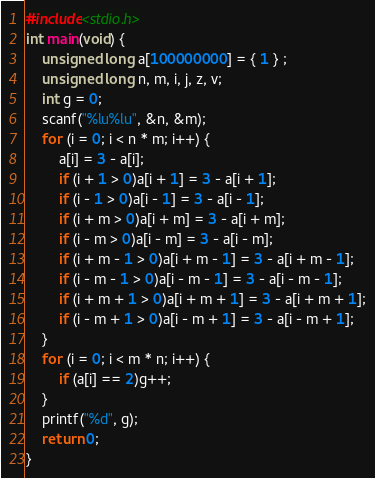Convert code to text. <code><loc_0><loc_0><loc_500><loc_500><_C_>#include<stdio.h>
int main(void) {
	unsigned long a[100000000] = { 1 } ;
	unsigned long n, m, i, j, z, v;
	int g = 0;
	scanf("%lu%lu", &n, &m);
	for (i = 0; i < n * m; i++) {
		a[i] = 3 - a[i];
		if (i + 1 > 0)a[i + 1] = 3 - a[i + 1];
		if (i - 1 > 0)a[i - 1] = 3 - a[i - 1];
		if (i + m > 0)a[i + m] = 3 - a[i + m];
		if (i - m > 0)a[i - m] = 3 - a[i - m];
		if (i + m - 1 > 0)a[i + m - 1] = 3 - a[i + m - 1];
		if (i - m - 1 > 0)a[i - m - 1] = 3 - a[i - m - 1];
		if (i + m + 1 > 0)a[i + m + 1] = 3 - a[i + m + 1];
		if (i - m + 1 > 0)a[i - m + 1] = 3 - a[i - m + 1];
	}
	for (i = 0; i < m * n; i++) {
		if (a[i] == 2)g++;
	}
	printf("%d", g);
	return 0;
}</code> 